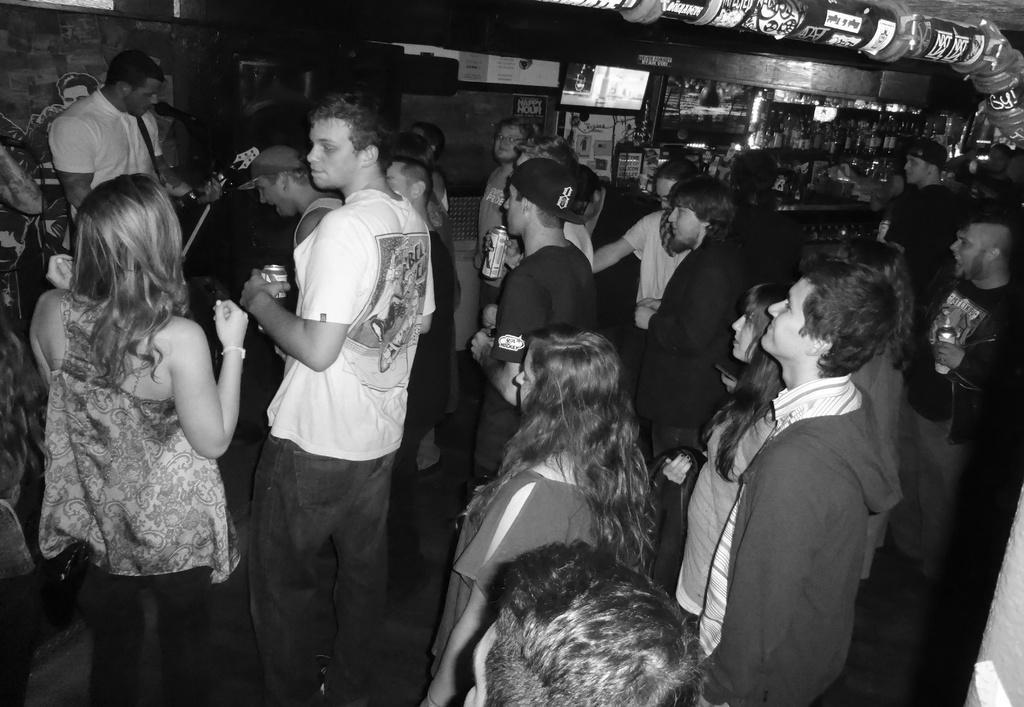Describe this image in one or two sentences. In the foreground I can see a group of people are standing on the floor and are holding cans in their hand. In the background I can see a shop, AC duct, chairs, bottles, posters, musical instruments, screen and wall. This image is taken may be during night in a bar. 